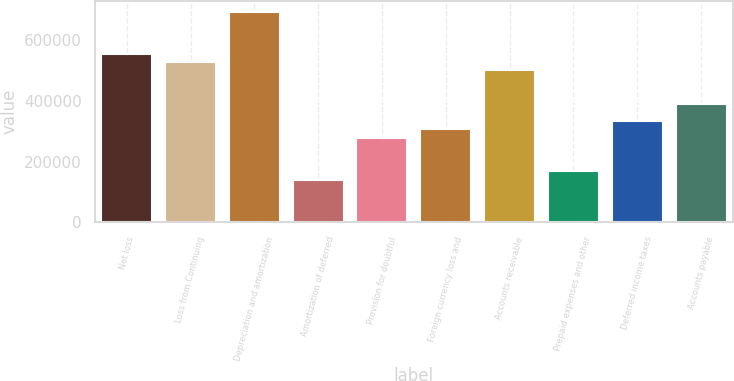Convert chart. <chart><loc_0><loc_0><loc_500><loc_500><bar_chart><fcel>Net loss<fcel>Loss from Continuing<fcel>Depreciation and amortization<fcel>Amortization of deferred<fcel>Provision for doubtful<fcel>Foreign currency loss and<fcel>Accounts receivable<fcel>Prepaid expenses and other<fcel>Deferred income taxes<fcel>Accounts payable<nl><fcel>554451<fcel>526820<fcel>692608<fcel>139978<fcel>278136<fcel>305768<fcel>499188<fcel>167610<fcel>333399<fcel>388662<nl></chart> 